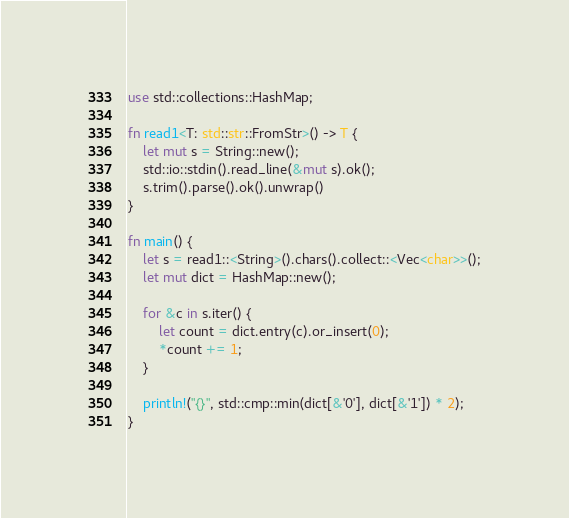<code> <loc_0><loc_0><loc_500><loc_500><_Rust_>use std::collections::HashMap;

fn read1<T: std::str::FromStr>() -> T {
    let mut s = String::new();
    std::io::stdin().read_line(&mut s).ok();
    s.trim().parse().ok().unwrap()
}

fn main() {
    let s = read1::<String>().chars().collect::<Vec<char>>();
    let mut dict = HashMap::new();

    for &c in s.iter() {
        let count = dict.entry(c).or_insert(0);
        *count += 1;
    }

    println!("{}", std::cmp::min(dict[&'0'], dict[&'1']) * 2);
}</code> 